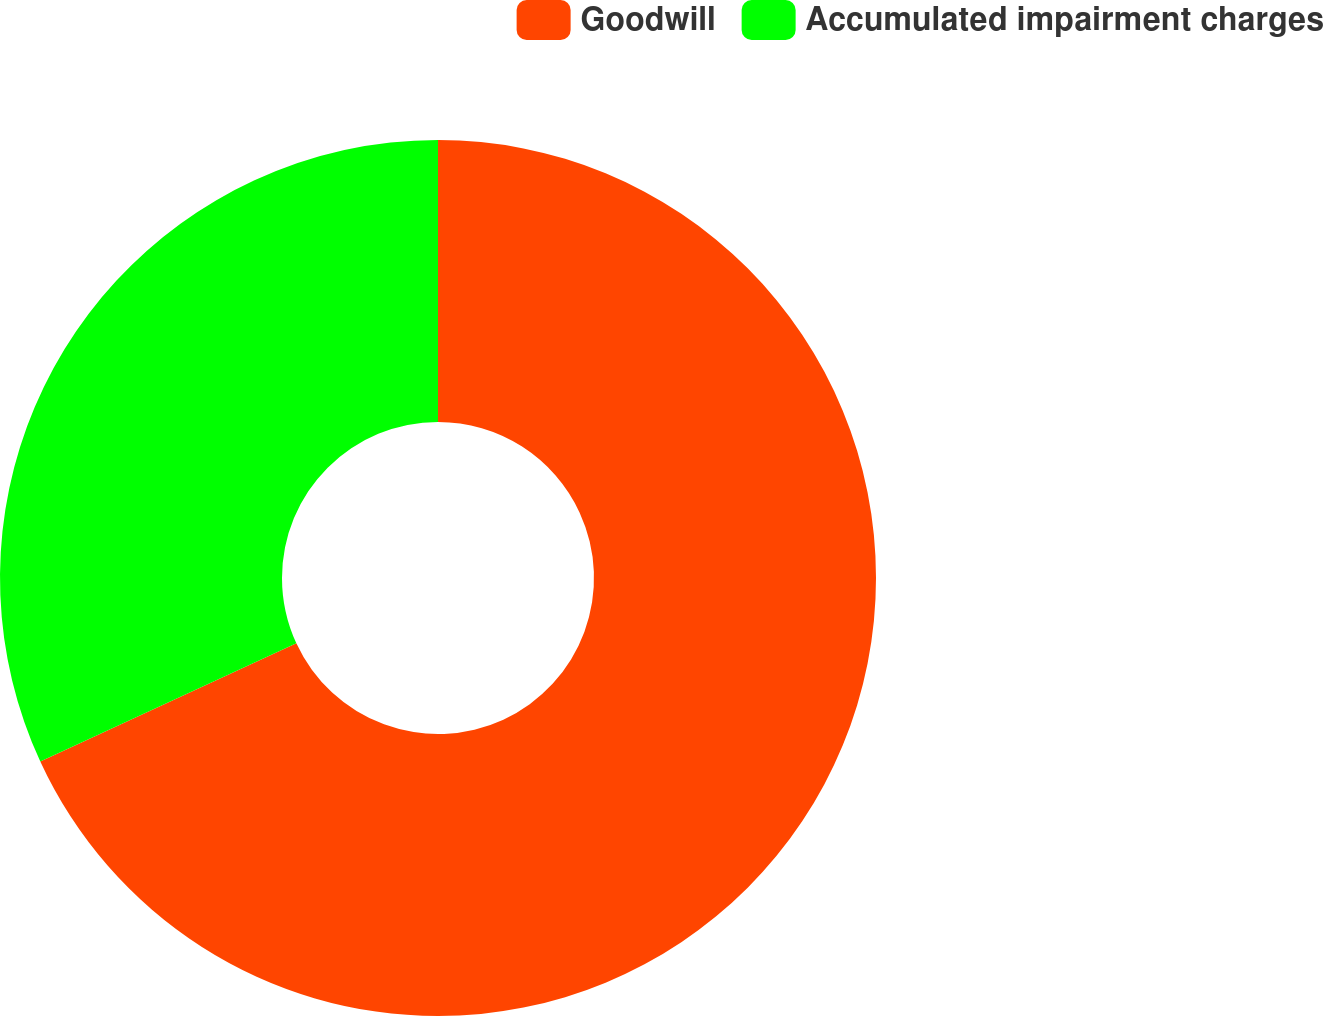Convert chart. <chart><loc_0><loc_0><loc_500><loc_500><pie_chart><fcel>Goodwill<fcel>Accumulated impairment charges<nl><fcel>68.12%<fcel>31.88%<nl></chart> 